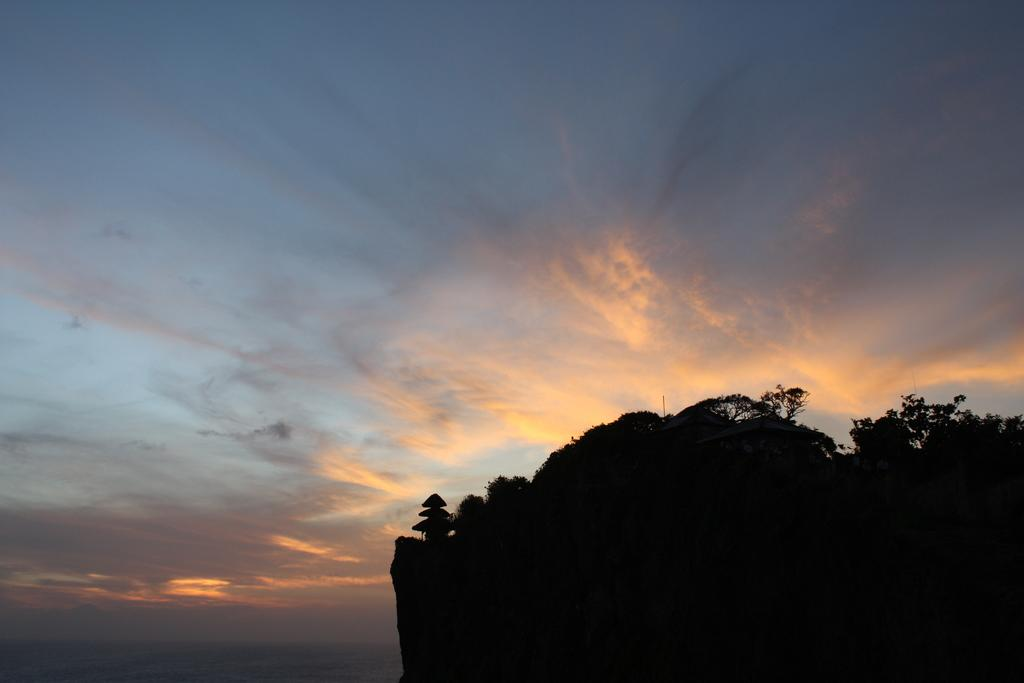What type of vegetation can be seen on the right side of the image? There are trees on a mountain on the right side of the image. What is visible in the background of the image? There are clouds in the background of the image. What color is the sky in the image? The sky is blue in the image. How many kittens are playing in the field on the left side of the image? There is no field or kittens present in the image; it features trees on a mountain and clouds in the background. 